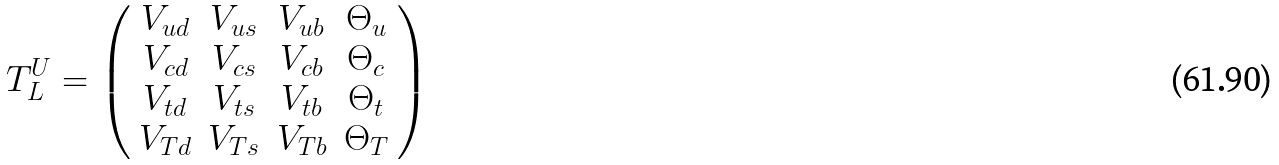Convert formula to latex. <formula><loc_0><loc_0><loc_500><loc_500>T ^ { U } _ { L } = \left ( \begin{array} { c c c c } V _ { u d } & V _ { u s } & V _ { u b } & \Theta _ { u } \\ V _ { c d } & V _ { c s } & V _ { c b } & \Theta _ { c } \\ V _ { t d } & V _ { t s } & V _ { t b } & \Theta _ { t } \\ V _ { T d } & V _ { T s } & V _ { T b } & \Theta _ { T } \end{array} \right )</formula> 